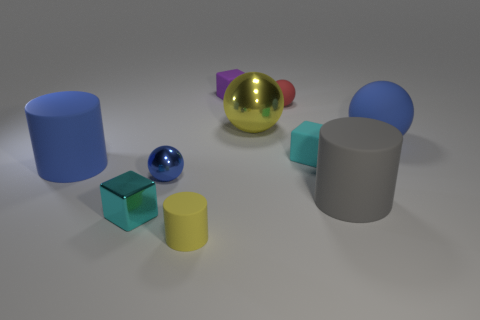What number of tiny cyan blocks are there?
Provide a short and direct response. 2. There is a large yellow shiny thing; is its shape the same as the cyan thing behind the big blue rubber cylinder?
Your answer should be very brief. No. Are there fewer large rubber spheres to the left of the purple matte thing than blue cylinders in front of the tiny cyan metal block?
Ensure brevity in your answer.  No. Is the shape of the large metallic thing the same as the cyan rubber object?
Your answer should be compact. No. What is the size of the blue shiny sphere?
Your answer should be compact. Small. There is a small object that is to the right of the big metal thing and in front of the big blue ball; what is its color?
Your answer should be very brief. Cyan. Is the number of tiny rubber blocks greater than the number of large purple matte objects?
Provide a succinct answer. Yes. How many objects are green rubber things or cubes in front of the small matte ball?
Provide a short and direct response. 2. Do the purple block and the cyan rubber cube have the same size?
Provide a short and direct response. Yes. There is a big gray rubber cylinder; are there any large balls behind it?
Your answer should be very brief. Yes. 